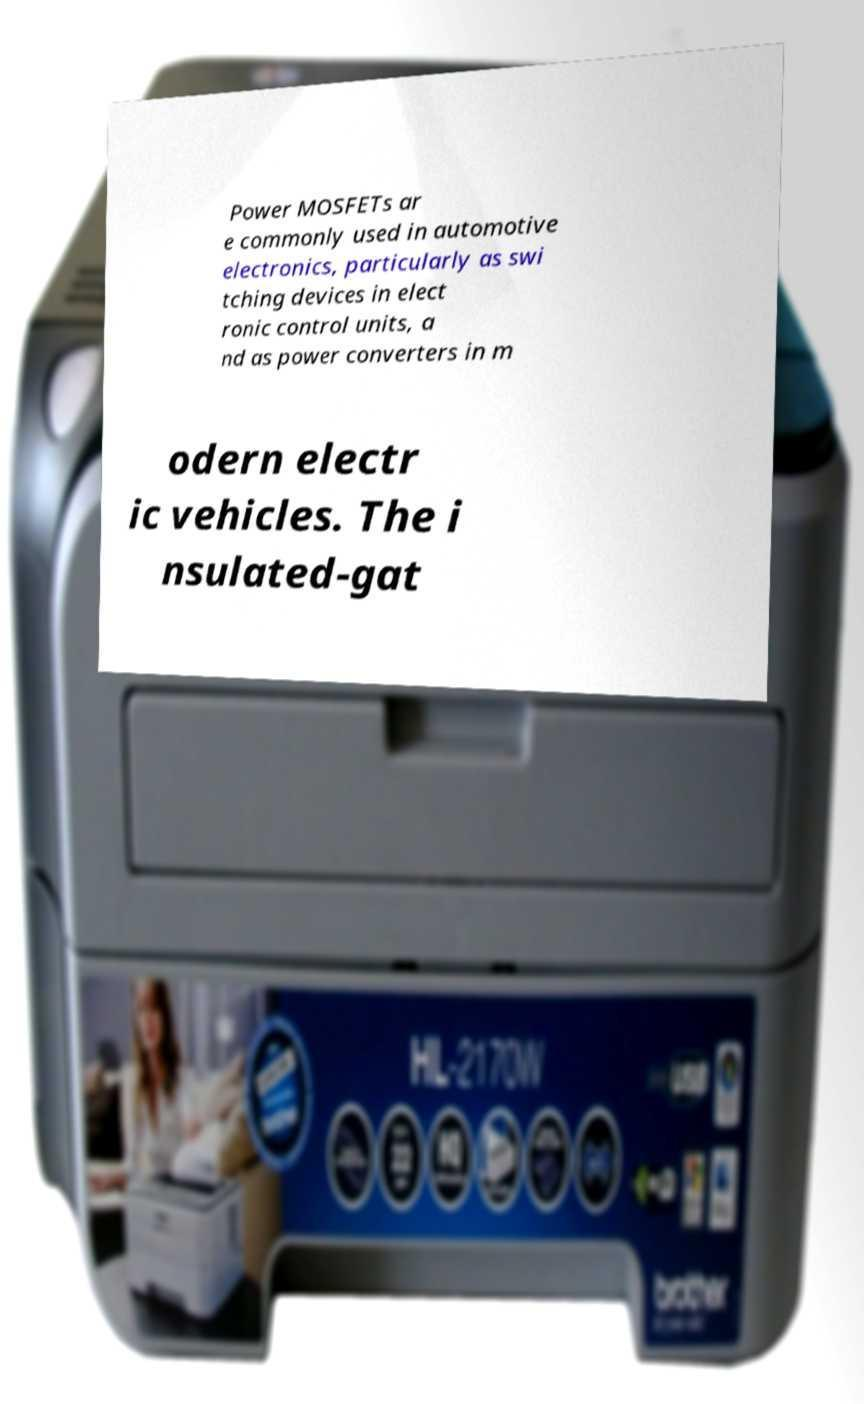Can you accurately transcribe the text from the provided image for me? Power MOSFETs ar e commonly used in automotive electronics, particularly as swi tching devices in elect ronic control units, a nd as power converters in m odern electr ic vehicles. The i nsulated-gat 